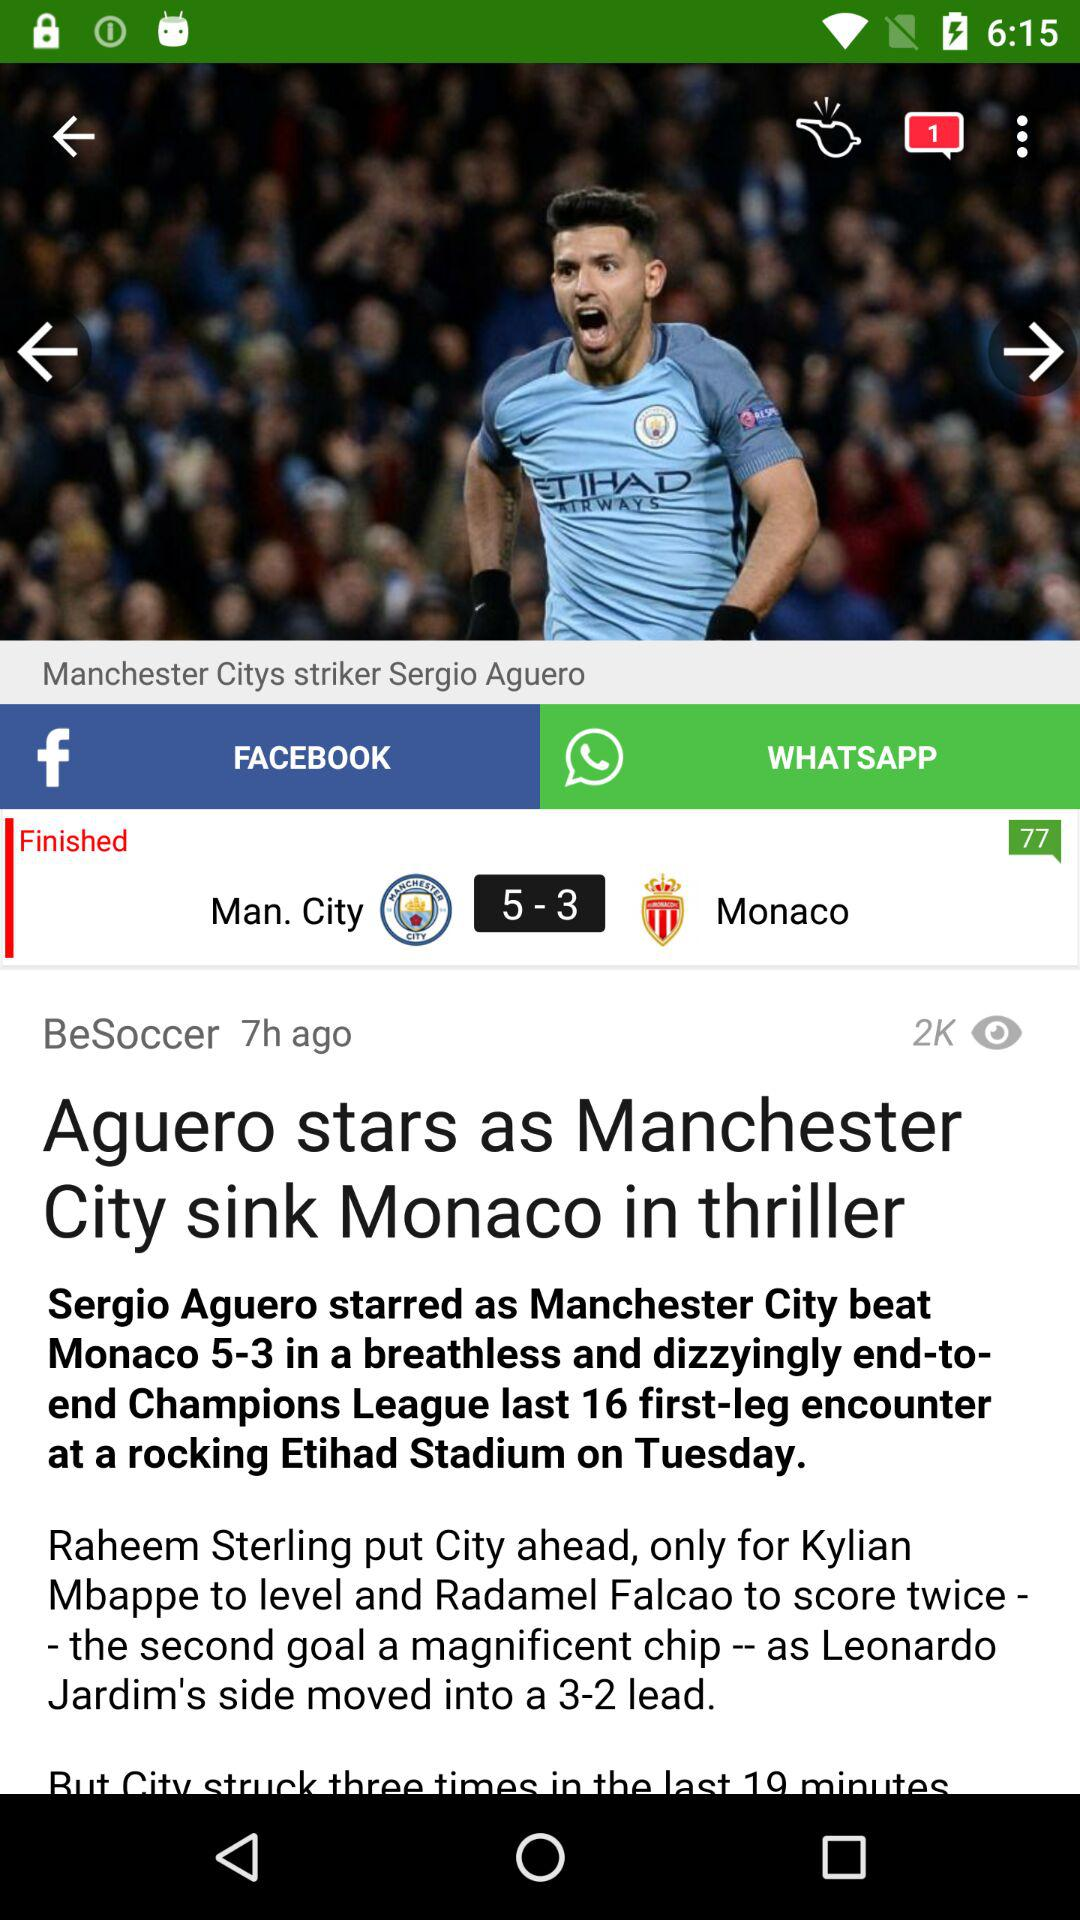How many goals did Man. City score?
Answer the question using a single word or phrase. 5 